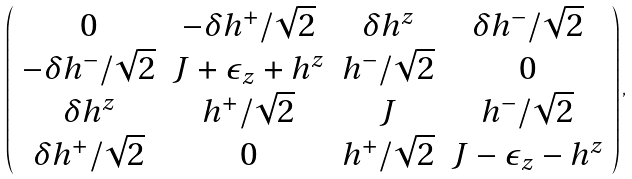Convert formula to latex. <formula><loc_0><loc_0><loc_500><loc_500>\left ( \begin{array} { c c c c } 0 & - \delta h ^ { + } / \sqrt { 2 } & \delta h ^ { z } & \delta h ^ { - } / \sqrt { 2 } \\ - \delta h ^ { - } / \sqrt { 2 } & J + \epsilon _ { z } + h ^ { z } & h ^ { - } / \sqrt { 2 } & 0 \\ \delta h ^ { z } & h ^ { + } / \sqrt { 2 } & J & h ^ { - } / \sqrt { 2 } \\ \delta h ^ { + } / \sqrt { 2 } & 0 & h ^ { + } / \sqrt { 2 } & J - \epsilon _ { z } - h ^ { z } \end{array} \right ) ,</formula> 